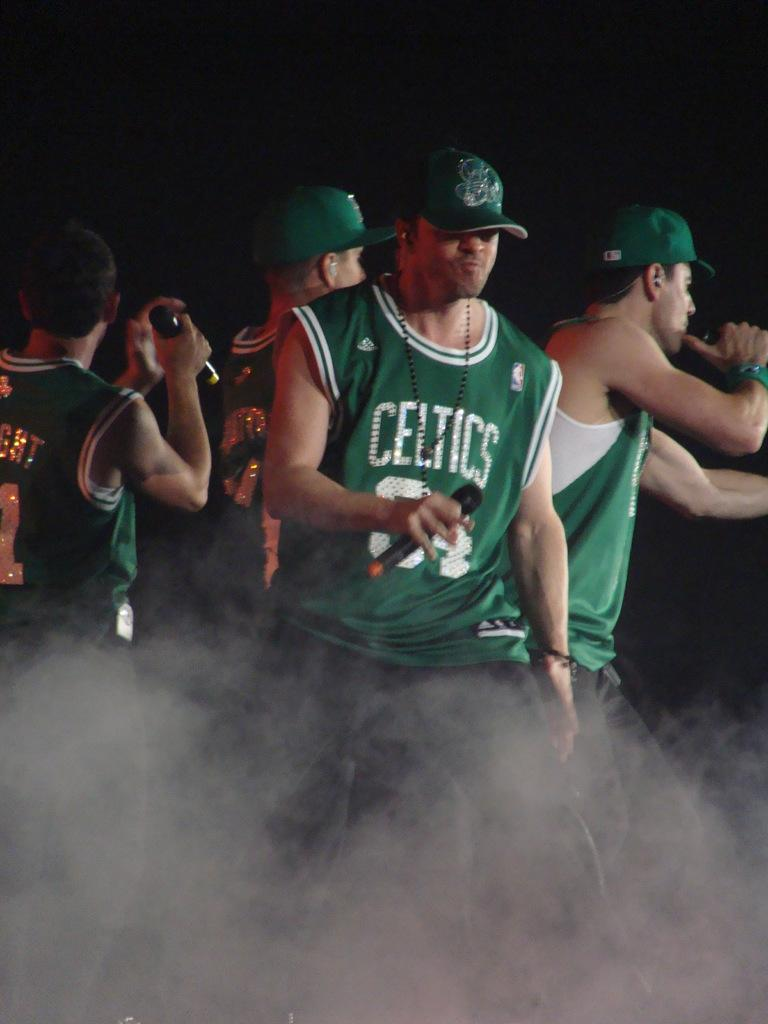<image>
Provide a brief description of the given image. men wearing green celtics jerseys stand on stage in a cloud of smoke 